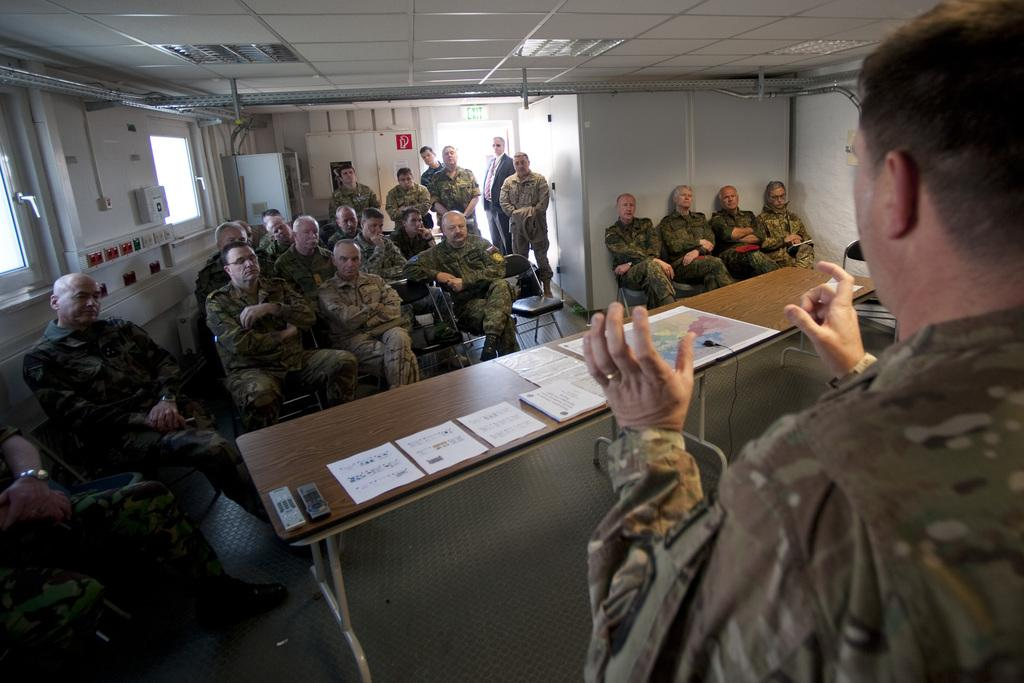What are the people in the image doing? The people in the image are sitting on chairs. What are the people wearing? The people are wearing uniforms. What is present in the image besides the people? There is a table in the image. What is on the table? There are papers on the table. What type of balloon is floating above the people in the image? There is no balloon present in the image. What kind of music is the band playing in the background of the image? There is no band present in the image. 